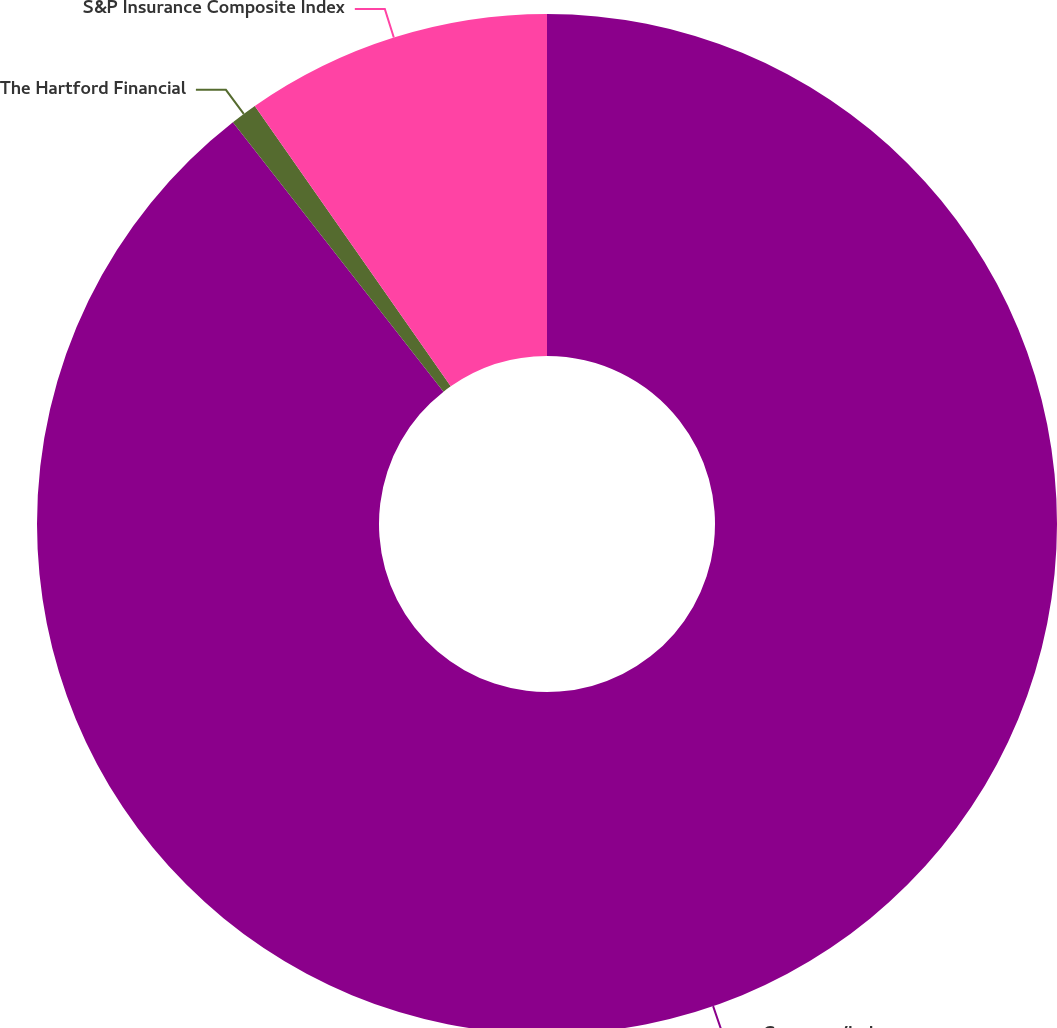Convert chart to OTSL. <chart><loc_0><loc_0><loc_500><loc_500><pie_chart><fcel>Company/Index<fcel>The Hartford Financial<fcel>S&P Insurance Composite Index<nl><fcel>89.44%<fcel>0.85%<fcel>9.71%<nl></chart> 